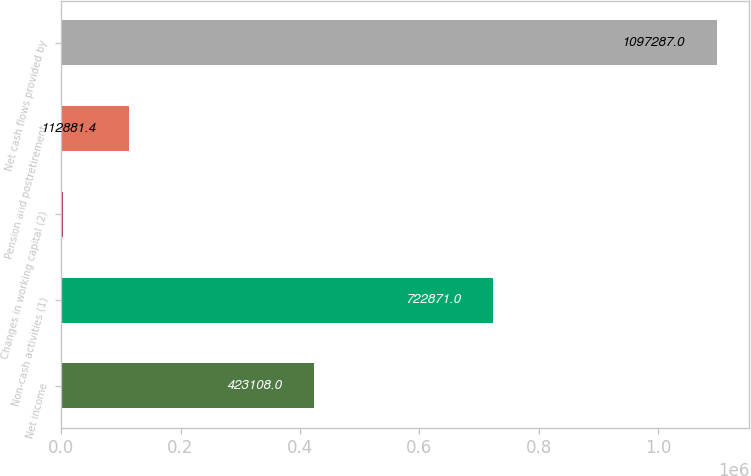Convert chart. <chart><loc_0><loc_0><loc_500><loc_500><bar_chart><fcel>Net income<fcel>Non-cash activities (1)<fcel>Changes in working capital (2)<fcel>Pension and postretirement<fcel>Net cash flows provided by<nl><fcel>423108<fcel>722871<fcel>3503<fcel>112881<fcel>1.09729e+06<nl></chart> 